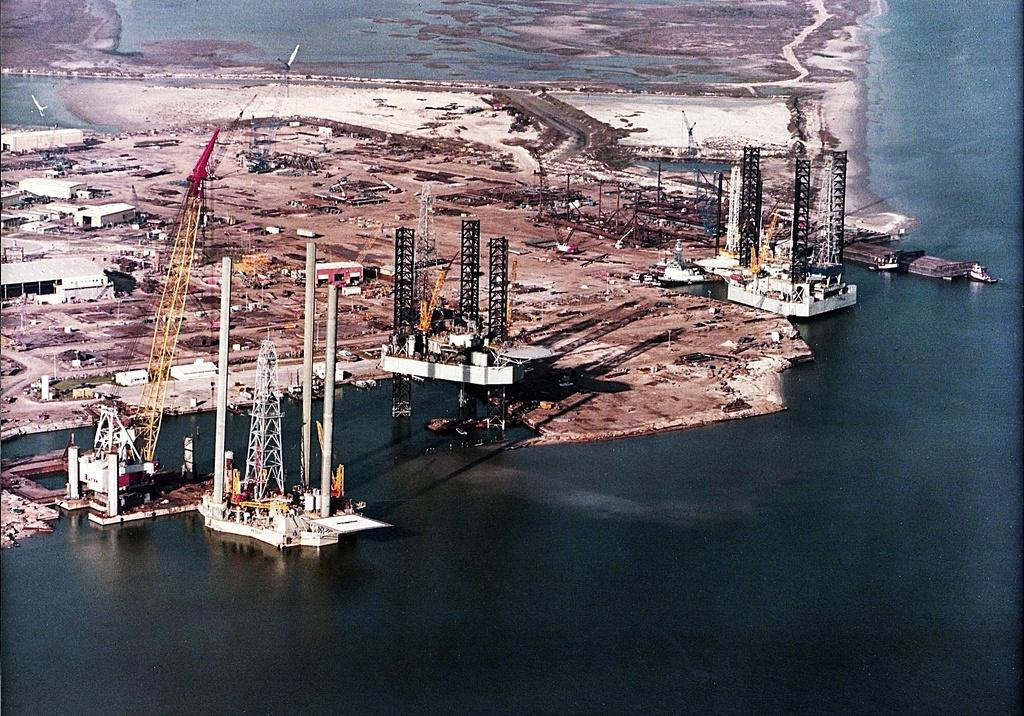What is the primary element visible in the image? There is water in the image. What structures can be seen in the image? There are towers and cranes visible in the image. What might be used to provide shade on the ground in the image? There are shades on the ground in the image. Can you hear the cook whistling while preparing food in the image? There is no cook or whistling present in the image; it primarily features water, towers, cranes, and shades on the ground. 